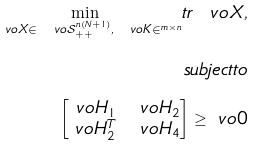<formula> <loc_0><loc_0><loc_500><loc_500>\underset { \ v o { X } \in \ v o { \mathcal { S } } _ { + + } ^ { n ( N + 1 ) } , \ v o { K } \in \real ^ { m \times n } } { \min } t r \ v o { X } , \\ s u b j e c t t o \\ \begin{bmatrix} \ v o { H } _ { 1 } & \ v o { H } _ { 2 } \\ \ v o { H } _ { 2 } ^ { T } & \ v o { H } _ { 4 } \end{bmatrix} \geq \ v o { 0 }</formula> 